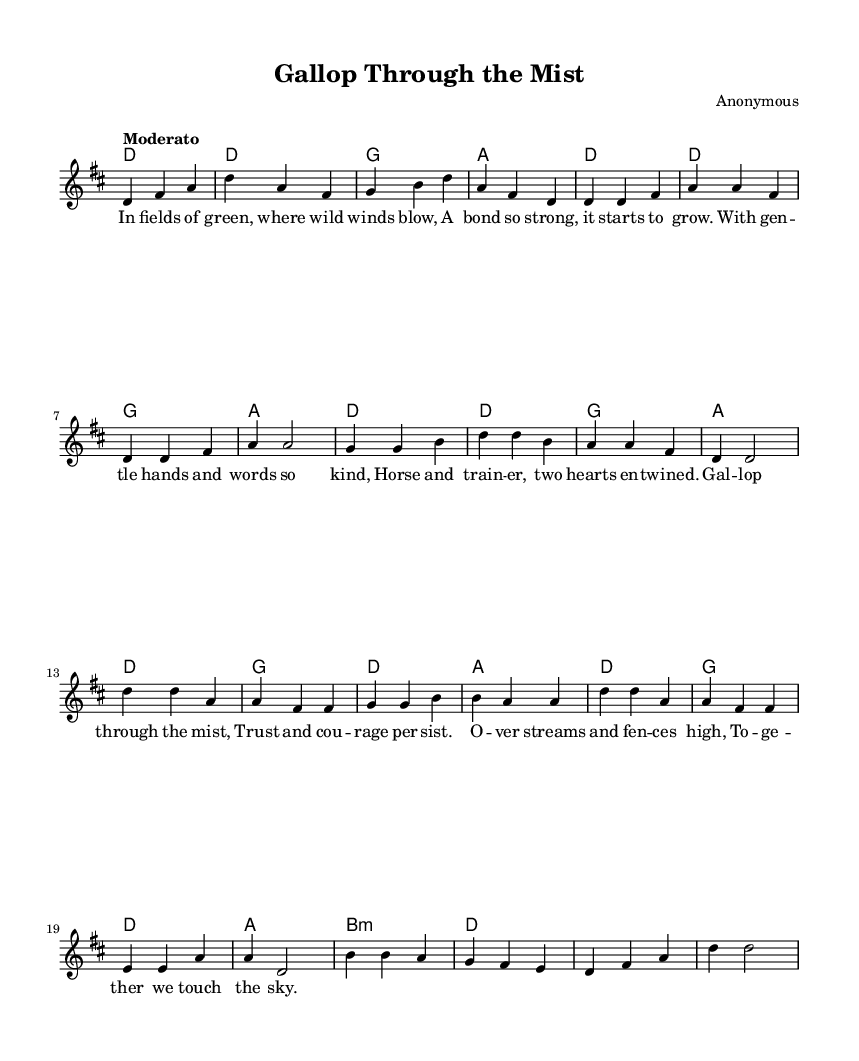What is the key signature of this music? The key signature is indicated at the beginning of the piece and shows two sharps, which corresponds to D major.
Answer: D major What is the time signature of this music? The time signature is shown at the start of the score and is labeled as 3/4, meaning there are three beats per measure and the quarter note receives one beat.
Answer: 3/4 What is the tempo marking for the piece? The tempo marking appears above the staff and is written as "Moderato," indicating a moderate speed for the performance.
Answer: Moderato How many measures are there in the chorus? By counting the musical segments in the chorus section, there are four measures that make up the chorus.
Answer: Four What is the emotional theme of the lyrics? The lyrics describe a strong bond and trust between the horse and the trainer, set against the backdrop of overcoming obstacles together.
Answer: Bond and trust What is the structure of the song? The song consists of an introduction, a verse, a chorus, and a bridge, showcasing a typical folk ballad structure.
Answer: Intro, verse, chorus, bridge What is the significance of the title "Gallop Through the Mist"? The title suggests a journey or adventure, symbolizing the partnership and trust between the horse and trainer as they navigate through challenges.
Answer: Journey and adventure 